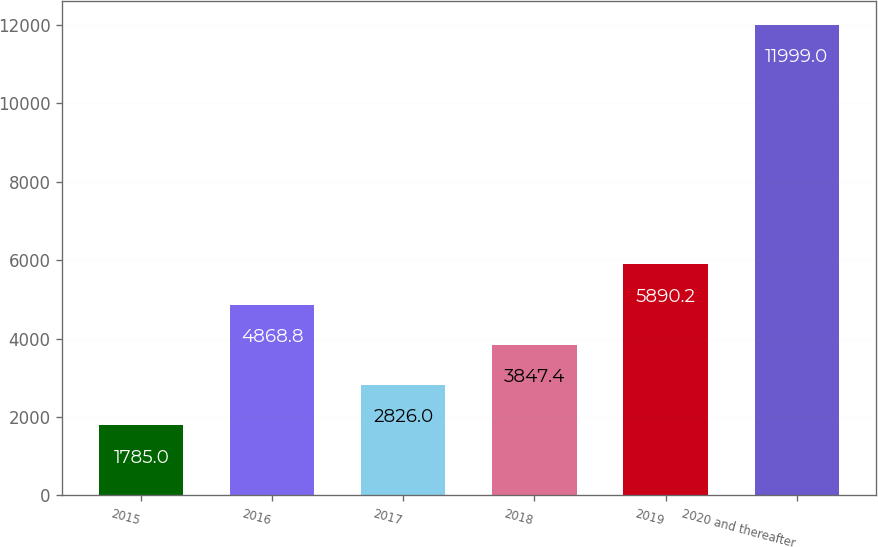Convert chart. <chart><loc_0><loc_0><loc_500><loc_500><bar_chart><fcel>2015<fcel>2016<fcel>2017<fcel>2018<fcel>2019<fcel>2020 and thereafter<nl><fcel>1785<fcel>4868.8<fcel>2826<fcel>3847.4<fcel>5890.2<fcel>11999<nl></chart> 